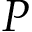<formula> <loc_0><loc_0><loc_500><loc_500>P</formula> 